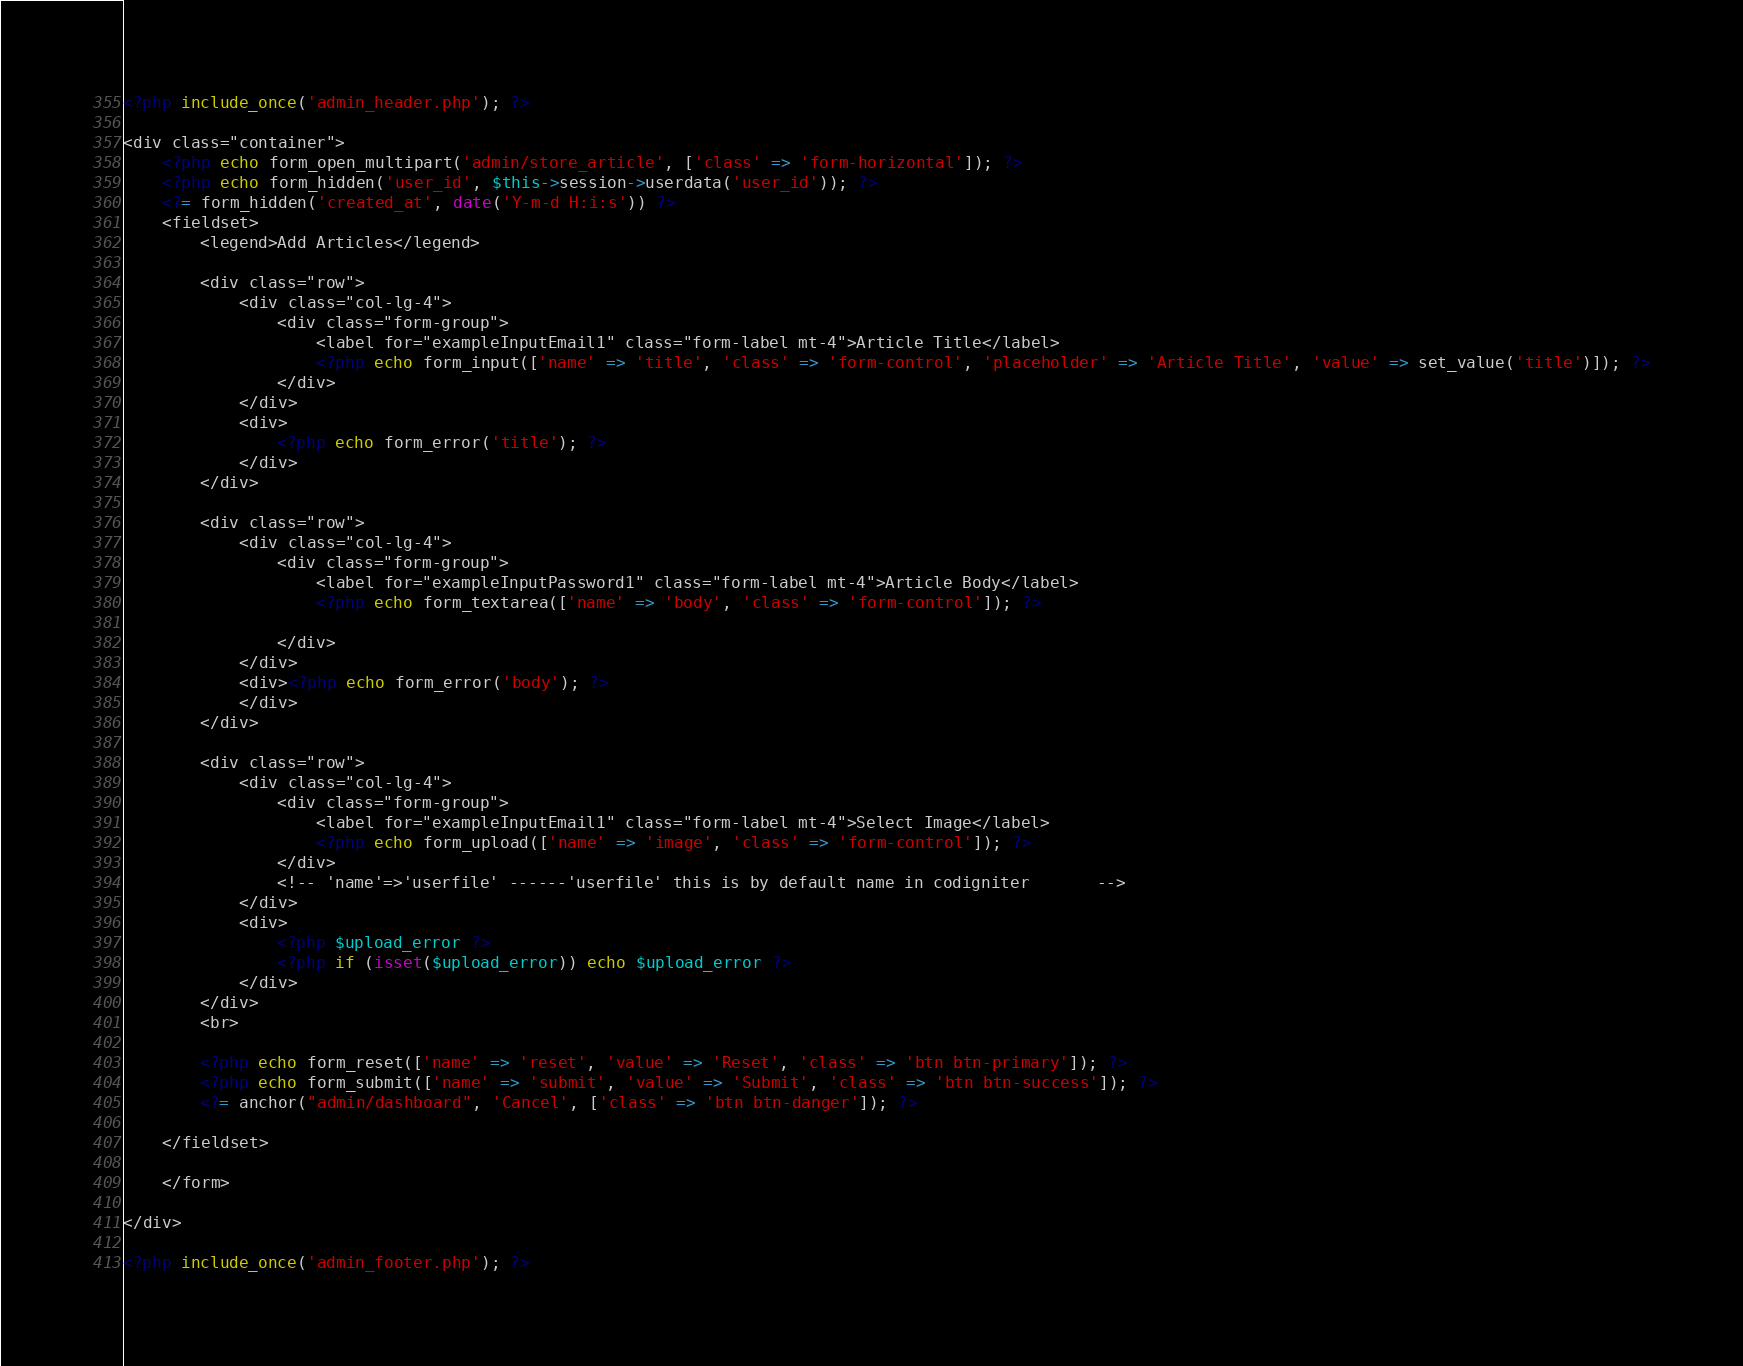<code> <loc_0><loc_0><loc_500><loc_500><_PHP_><?php include_once('admin_header.php'); ?>

<div class="container">
    <?php echo form_open_multipart('admin/store_article', ['class' => 'form-horizontal']); ?>
    <?php echo form_hidden('user_id', $this->session->userdata('user_id')); ?>
    <?= form_hidden('created_at', date('Y-m-d H:i:s')) ?>
    <fieldset>
        <legend>Add Articles</legend>

        <div class="row">
            <div class="col-lg-4">
                <div class="form-group">
                    <label for="exampleInputEmail1" class="form-label mt-4">Article Title</label>
                    <?php echo form_input(['name' => 'title', 'class' => 'form-control', 'placeholder' => 'Article Title', 'value' => set_value('title')]); ?>
                </div>
            </div>
            <div>
                <?php echo form_error('title'); ?>
            </div>
        </div>

        <div class="row">
            <div class="col-lg-4">
                <div class="form-group">
                    <label for="exampleInputPassword1" class="form-label mt-4">Article Body</label>
                    <?php echo form_textarea(['name' => 'body', 'class' => 'form-control']); ?>

                </div>
            </div>
            <div><?php echo form_error('body'); ?>
            </div>
        </div>

        <div class="row">
            <div class="col-lg-4">
                <div class="form-group">
                    <label for="exampleInputEmail1" class="form-label mt-4">Select Image</label>
                    <?php echo form_upload(['name' => 'image', 'class' => 'form-control']); ?>
                </div>
                <!-- 'name'=>'userfile' ------'userfile' this is by default name in codigniter       -->
            </div>
            <div>
                <?php $upload_error ?>
                <?php if (isset($upload_error)) echo $upload_error ?>
            </div>
        </div>
        <br>

        <?php echo form_reset(['name' => 'reset', 'value' => 'Reset', 'class' => 'btn btn-primary']); ?>
        <?php echo form_submit(['name' => 'submit', 'value' => 'Submit', 'class' => 'btn btn-success']); ?>
        <?= anchor("admin/dashboard", 'Cancel', ['class' => 'btn btn-danger']); ?>

    </fieldset>

    </form>

</div>

<?php include_once('admin_footer.php'); ?></code> 